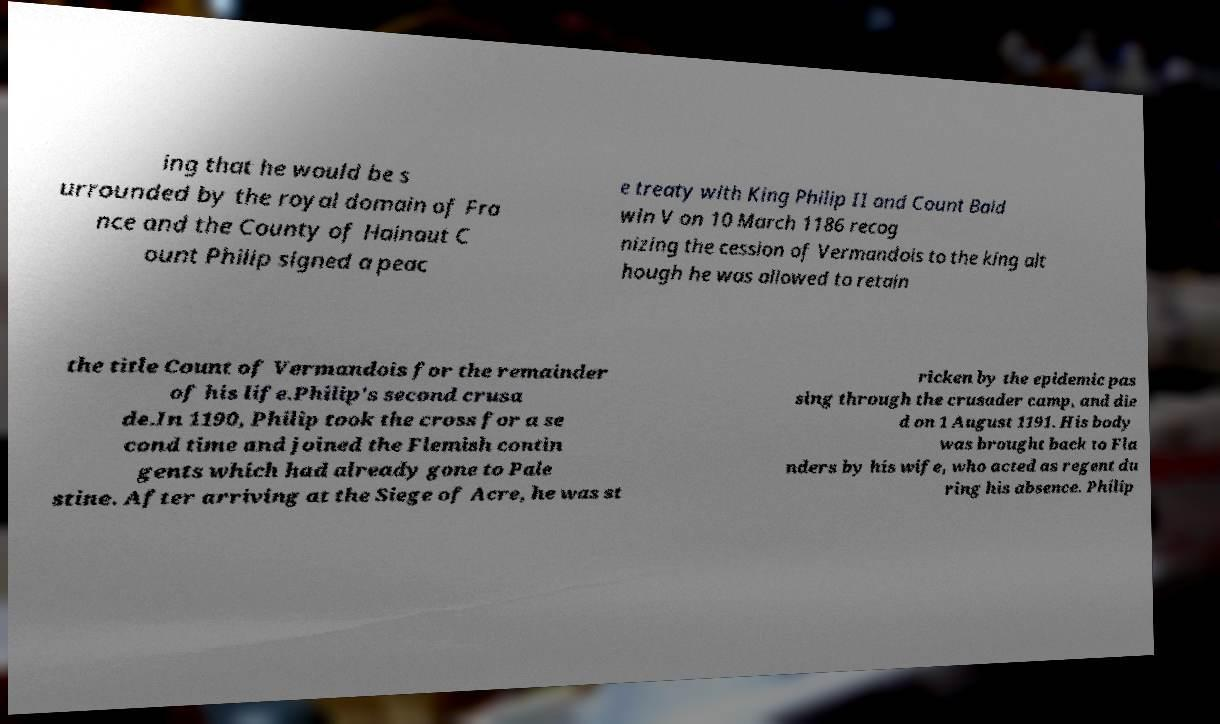Can you read and provide the text displayed in the image?This photo seems to have some interesting text. Can you extract and type it out for me? ing that he would be s urrounded by the royal domain of Fra nce and the County of Hainaut C ount Philip signed a peac e treaty with King Philip II and Count Bald win V on 10 March 1186 recog nizing the cession of Vermandois to the king alt hough he was allowed to retain the title Count of Vermandois for the remainder of his life.Philip's second crusa de.In 1190, Philip took the cross for a se cond time and joined the Flemish contin gents which had already gone to Pale stine. After arriving at the Siege of Acre, he was st ricken by the epidemic pas sing through the crusader camp, and die d on 1 August 1191. His body was brought back to Fla nders by his wife, who acted as regent du ring his absence. Philip 